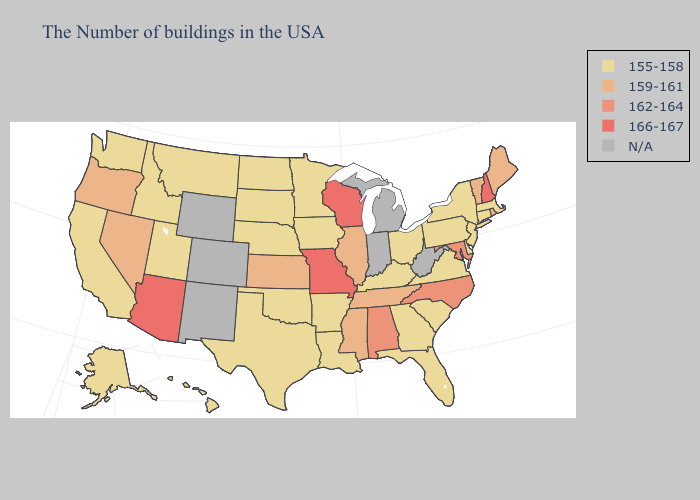What is the highest value in states that border California?
Be succinct. 166-167. How many symbols are there in the legend?
Keep it brief. 5. Among the states that border Louisiana , does Mississippi have the lowest value?
Quick response, please. No. Among the states that border Georgia , which have the highest value?
Short answer required. North Carolina, Alabama. Does North Carolina have the highest value in the South?
Write a very short answer. Yes. Which states have the lowest value in the MidWest?
Give a very brief answer. Ohio, Minnesota, Iowa, Nebraska, South Dakota, North Dakota. What is the value of North Carolina?
Write a very short answer. 162-164. Does Nevada have the lowest value in the USA?
Be succinct. No. Among the states that border Kentucky , does Ohio have the lowest value?
Be succinct. Yes. What is the lowest value in the South?
Give a very brief answer. 155-158. Name the states that have a value in the range 166-167?
Write a very short answer. New Hampshire, Wisconsin, Missouri, Arizona. What is the highest value in the South ?
Concise answer only. 162-164. Name the states that have a value in the range 166-167?
Give a very brief answer. New Hampshire, Wisconsin, Missouri, Arizona. Among the states that border Montana , which have the lowest value?
Short answer required. South Dakota, North Dakota, Idaho. Does the first symbol in the legend represent the smallest category?
Give a very brief answer. Yes. 